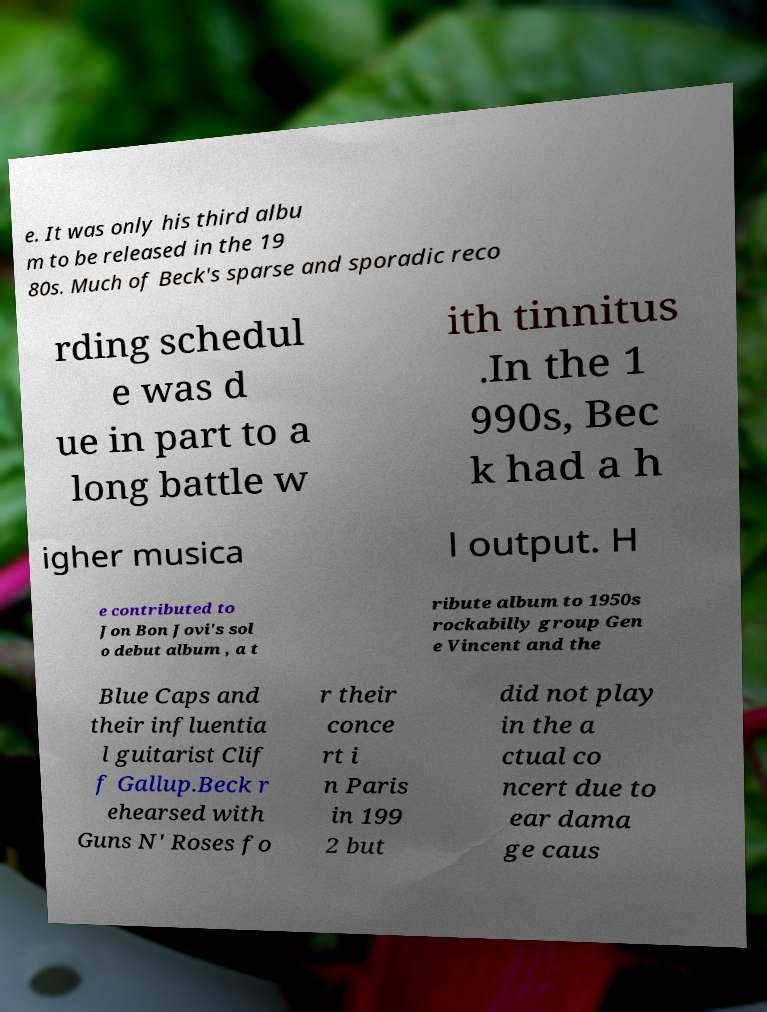Could you assist in decoding the text presented in this image and type it out clearly? e. It was only his third albu m to be released in the 19 80s. Much of Beck's sparse and sporadic reco rding schedul e was d ue in part to a long battle w ith tinnitus .In the 1 990s, Bec k had a h igher musica l output. H e contributed to Jon Bon Jovi's sol o debut album , a t ribute album to 1950s rockabilly group Gen e Vincent and the Blue Caps and their influentia l guitarist Clif f Gallup.Beck r ehearsed with Guns N' Roses fo r their conce rt i n Paris in 199 2 but did not play in the a ctual co ncert due to ear dama ge caus 